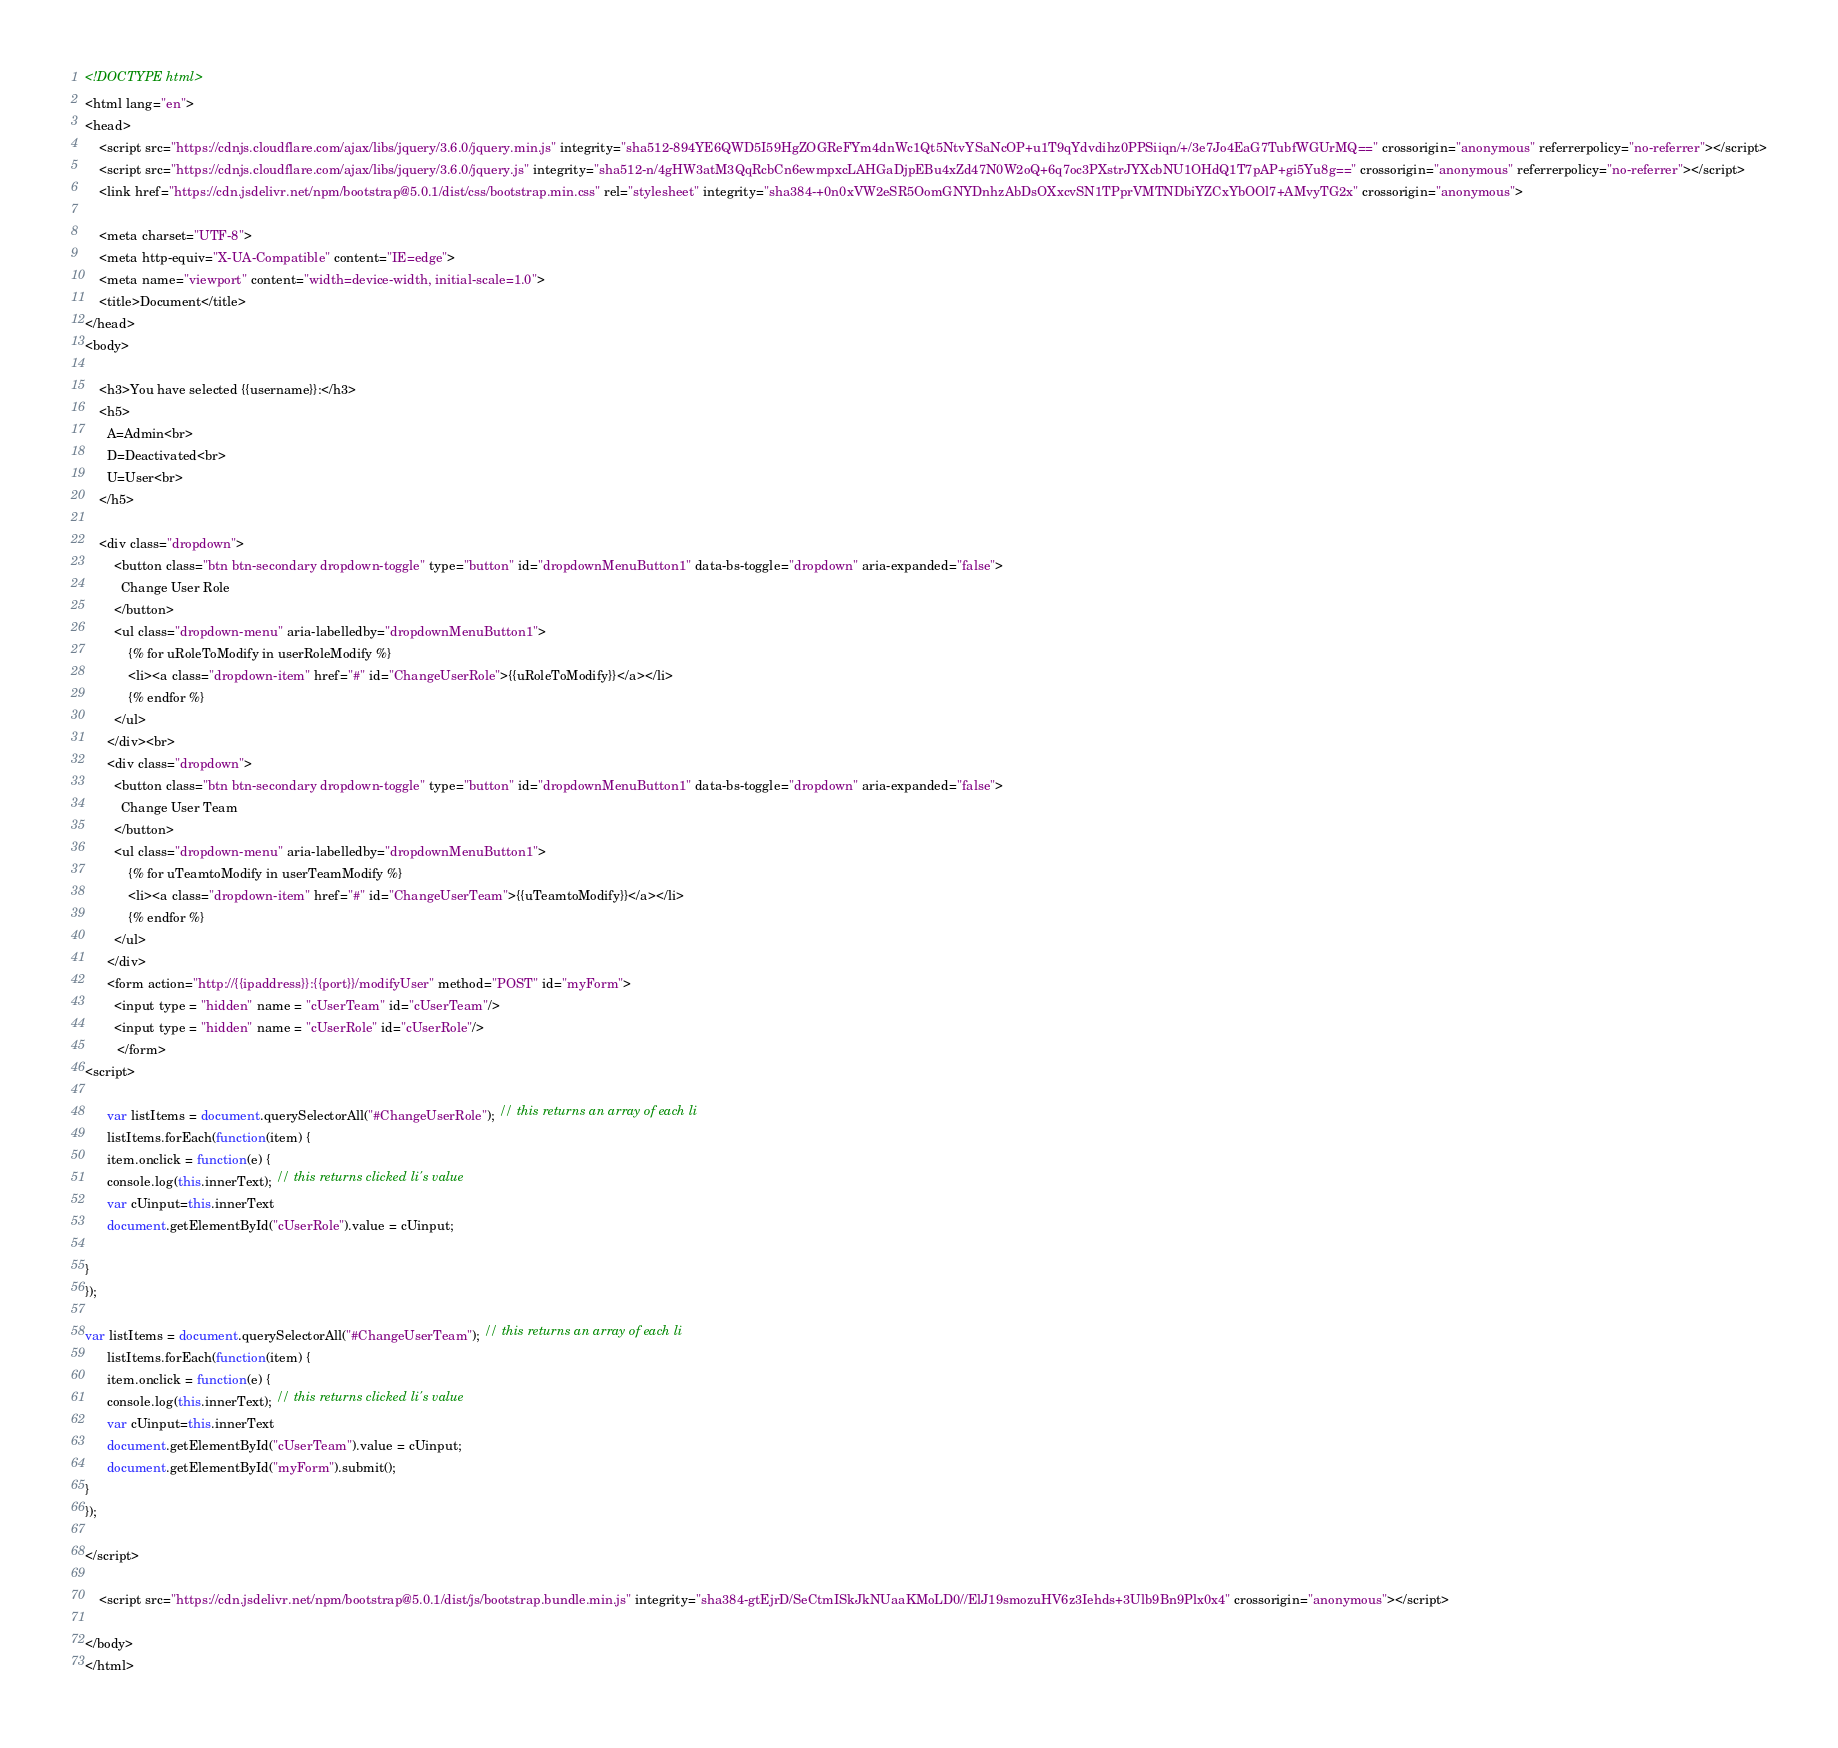Convert code to text. <code><loc_0><loc_0><loc_500><loc_500><_HTML_><!DOCTYPE html>
<html lang="en">
<head>
    <script src="https://cdnjs.cloudflare.com/ajax/libs/jquery/3.6.0/jquery.min.js" integrity="sha512-894YE6QWD5I59HgZOGReFYm4dnWc1Qt5NtvYSaNcOP+u1T9qYdvdihz0PPSiiqn/+/3e7Jo4EaG7TubfWGUrMQ==" crossorigin="anonymous" referrerpolicy="no-referrer"></script>
    <script src="https://cdnjs.cloudflare.com/ajax/libs/jquery/3.6.0/jquery.js" integrity="sha512-n/4gHW3atM3QqRcbCn6ewmpxcLAHGaDjpEBu4xZd47N0W2oQ+6q7oc3PXstrJYXcbNU1OHdQ1T7pAP+gi5Yu8g==" crossorigin="anonymous" referrerpolicy="no-referrer"></script>
    <link href="https://cdn.jsdelivr.net/npm/bootstrap@5.0.1/dist/css/bootstrap.min.css" rel="stylesheet" integrity="sha384-+0n0xVW2eSR5OomGNYDnhzAbDsOXxcvSN1TPprVMTNDbiYZCxYbOOl7+AMvyTG2x" crossorigin="anonymous">

    <meta charset="UTF-8">
    <meta http-equiv="X-UA-Compatible" content="IE=edge">
    <meta name="viewport" content="width=device-width, initial-scale=1.0">
    <title>Document</title>
</head>
<body>

    <h3>You have selected {{username}}:</h3>
    <h5>
      A=Admin<br>
      D=Deactivated<br>
      U=User<br>
    </h5>
    
    <div class="dropdown">
        <button class="btn btn-secondary dropdown-toggle" type="button" id="dropdownMenuButton1" data-bs-toggle="dropdown" aria-expanded="false">
          Change User Role
        </button>
        <ul class="dropdown-menu" aria-labelledby="dropdownMenuButton1">
            {% for uRoleToModify in userRoleModify %}
            <li><a class="dropdown-item" href="#" id="ChangeUserRole">{{uRoleToModify}}</a></li>
            {% endfor %}
        </ul>
      </div><br>
      <div class="dropdown">
        <button class="btn btn-secondary dropdown-toggle" type="button" id="dropdownMenuButton1" data-bs-toggle="dropdown" aria-expanded="false">
          Change User Team
        </button>
        <ul class="dropdown-menu" aria-labelledby="dropdownMenuButton1">
            {% for uTeamtoModify in userTeamModify %}
            <li><a class="dropdown-item" href="#" id="ChangeUserTeam">{{uTeamtoModify}}</a></li>
            {% endfor %}
        </ul>
      </div>
      <form action="http://{{ipaddress}}:{{port}}/modifyUser" method="POST" id="myForm">
        <input type = "hidden" name = "cUserTeam" id="cUserTeam"/>
        <input type = "hidden" name = "cUserRole" id="cUserRole"/>
         </form>
<script>

      var listItems = document.querySelectorAll("#ChangeUserRole"); // this returns an array of each li
      listItems.forEach(function(item) {
      item.onclick = function(e) {
      console.log(this.innerText); // this returns clicked li's value
      var cUinput=this.innerText
      document.getElementById("cUserRole").value = cUinput;
     
}
});

var listItems = document.querySelectorAll("#ChangeUserTeam"); // this returns an array of each li
      listItems.forEach(function(item) {
      item.onclick = function(e) {
      console.log(this.innerText); // this returns clicked li's value
      var cUinput=this.innerText
      document.getElementById("cUserTeam").value = cUinput;
      document.getElementById("myForm").submit();
}
});

</script>

    <script src="https://cdn.jsdelivr.net/npm/bootstrap@5.0.1/dist/js/bootstrap.bundle.min.js" integrity="sha384-gtEjrD/SeCtmISkJkNUaaKMoLD0//ElJ19smozuHV6z3Iehds+3Ulb9Bn9Plx0x4" crossorigin="anonymous"></script>

</body>
</html></code> 